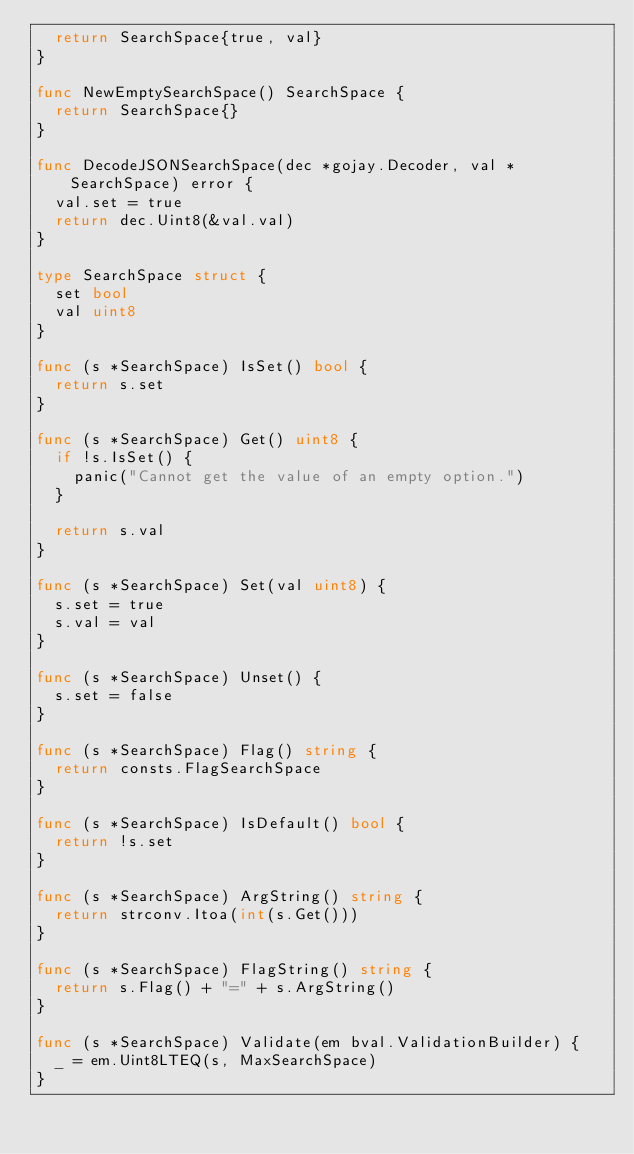<code> <loc_0><loc_0><loc_500><loc_500><_Go_>	return SearchSpace{true, val}
}

func NewEmptySearchSpace() SearchSpace {
	return SearchSpace{}
}

func DecodeJSONSearchSpace(dec *gojay.Decoder, val *SearchSpace) error {
	val.set = true
	return dec.Uint8(&val.val)
}

type SearchSpace struct {
	set bool
	val uint8
}

func (s *SearchSpace) IsSet() bool {
	return s.set
}

func (s *SearchSpace) Get() uint8 {
	if !s.IsSet() {
		panic("Cannot get the value of an empty option.")
	}

	return s.val
}

func (s *SearchSpace) Set(val uint8) {
	s.set = true
	s.val = val
}

func (s *SearchSpace) Unset() {
	s.set = false
}

func (s *SearchSpace) Flag() string {
	return consts.FlagSearchSpace
}

func (s *SearchSpace) IsDefault() bool {
	return !s.set
}

func (s *SearchSpace) ArgString() string {
	return strconv.Itoa(int(s.Get()))
}

func (s *SearchSpace) FlagString() string {
	return s.Flag() + "=" + s.ArgString()
}

func (s *SearchSpace) Validate(em bval.ValidationBuilder) {
	_ = em.Uint8LTEQ(s, MaxSearchSpace)
}
</code> 